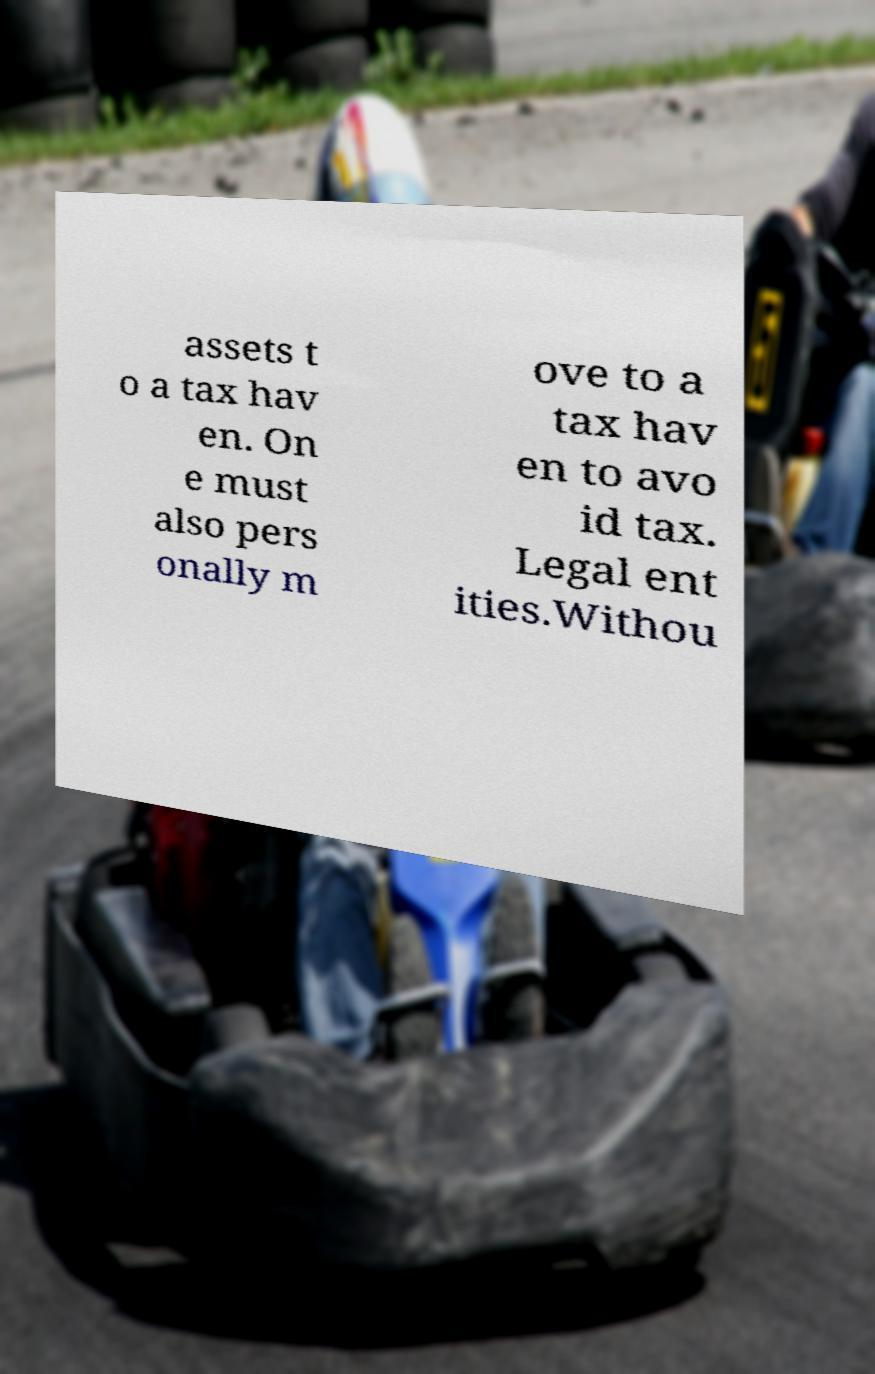I need the written content from this picture converted into text. Can you do that? assets t o a tax hav en. On e must also pers onally m ove to a tax hav en to avo id tax. Legal ent ities.Withou 